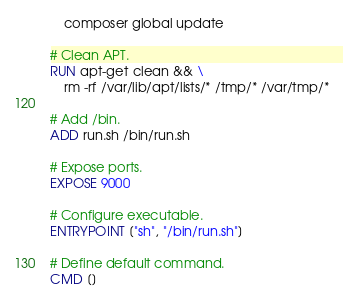Convert code to text. <code><loc_0><loc_0><loc_500><loc_500><_Dockerfile_>    composer global update

# Clean APT.
RUN apt-get clean && \
    rm -rf /var/lib/apt/lists/* /tmp/* /var/tmp/*

# Add /bin.
ADD run.sh /bin/run.sh

# Expose ports.
EXPOSE 9000

# Configure executable.
ENTRYPOINT ["sh", "/bin/run.sh"]

# Define default command.
CMD []
</code> 